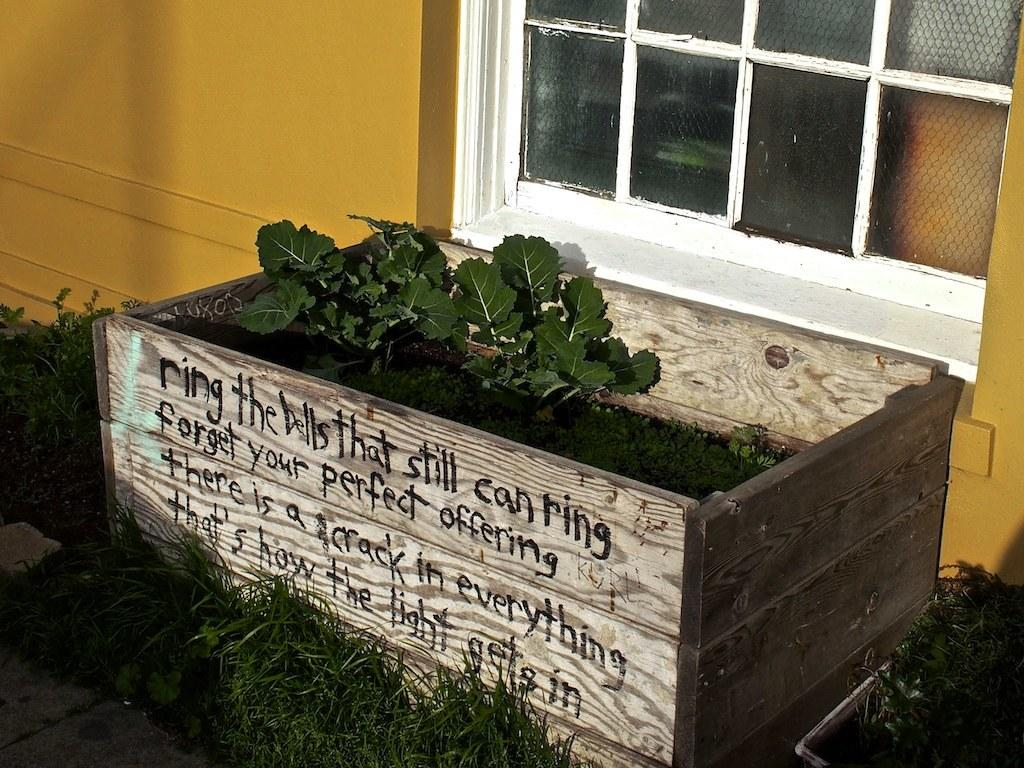What type of container holds the plants in the image? The plants are in a wooden box in the image. What can be found on the wooden box besides the plants? There is text on the wooden box. What architectural feature is present in the image? There is a wall with a glass window in the image. What type of vegetation is visible on the ground in the image? Grass is visible on the ground in the image. What color is the pig's hair in the image? There is no pig present in the image, so we cannot determine the color of its hair. 